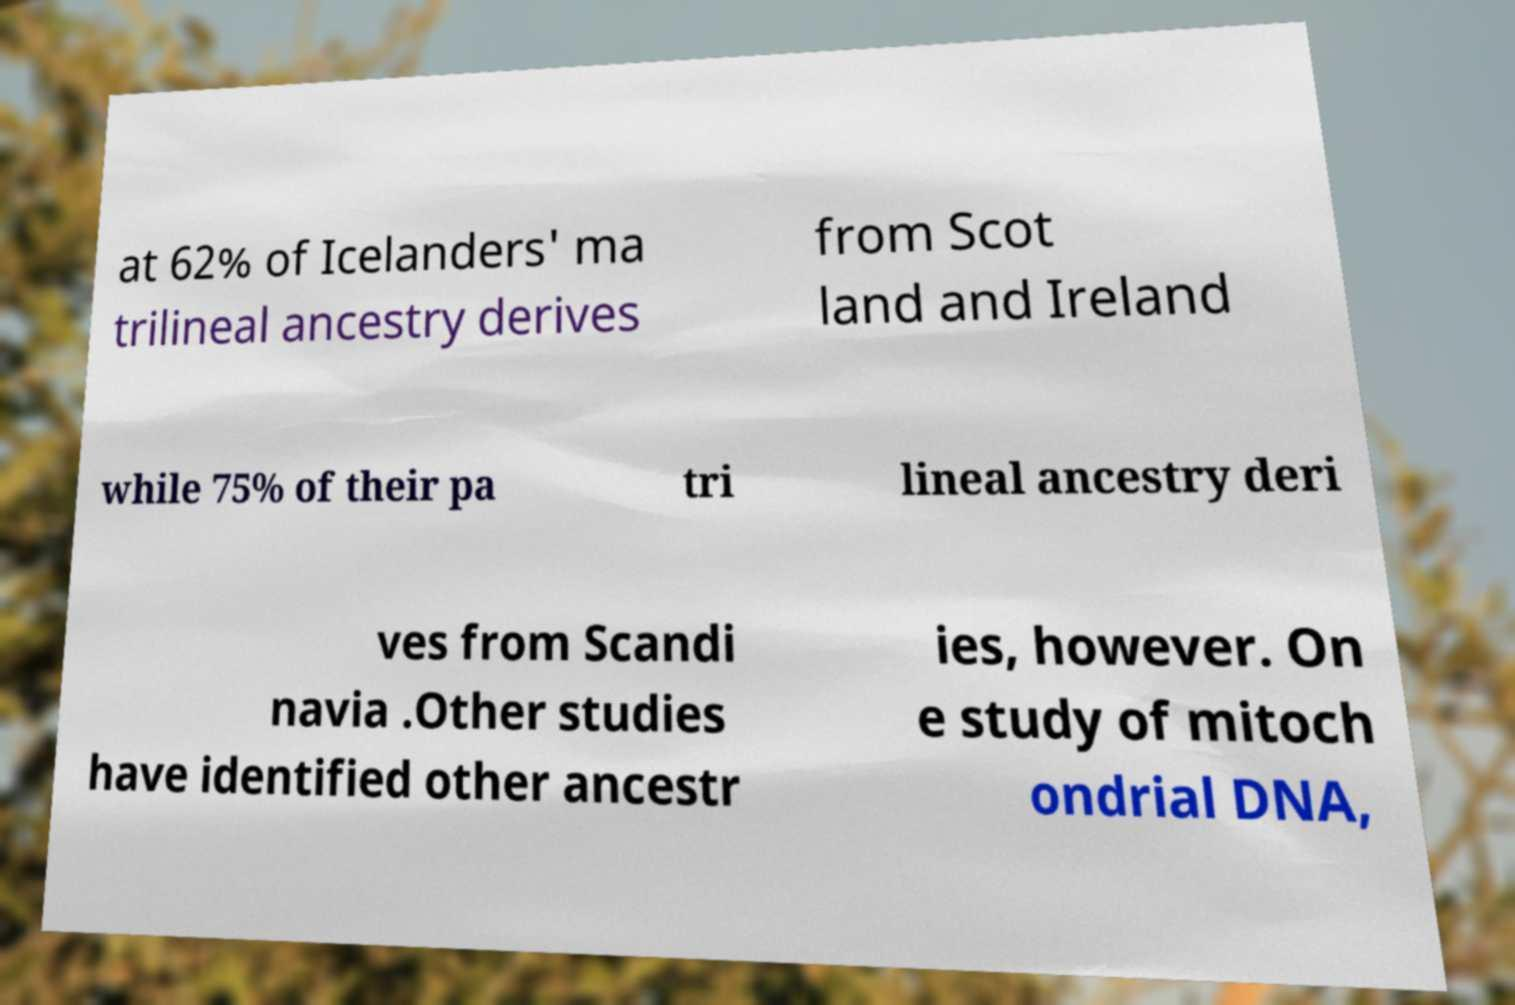Could you assist in decoding the text presented in this image and type it out clearly? at 62% of Icelanders' ma trilineal ancestry derives from Scot land and Ireland while 75% of their pa tri lineal ancestry deri ves from Scandi navia .Other studies have identified other ancestr ies, however. On e study of mitoch ondrial DNA, 